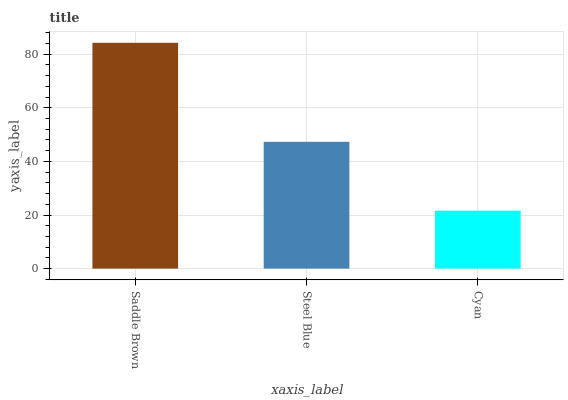Is Cyan the minimum?
Answer yes or no. Yes. Is Saddle Brown the maximum?
Answer yes or no. Yes. Is Steel Blue the minimum?
Answer yes or no. No. Is Steel Blue the maximum?
Answer yes or no. No. Is Saddle Brown greater than Steel Blue?
Answer yes or no. Yes. Is Steel Blue less than Saddle Brown?
Answer yes or no. Yes. Is Steel Blue greater than Saddle Brown?
Answer yes or no. No. Is Saddle Brown less than Steel Blue?
Answer yes or no. No. Is Steel Blue the high median?
Answer yes or no. Yes. Is Steel Blue the low median?
Answer yes or no. Yes. Is Cyan the high median?
Answer yes or no. No. Is Cyan the low median?
Answer yes or no. No. 